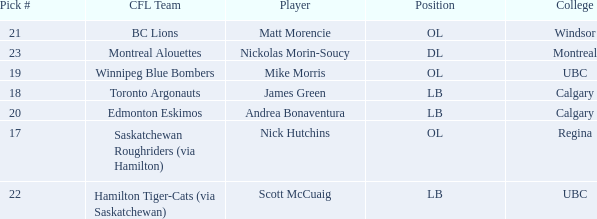What position is the player who went to Regina?  OL. 